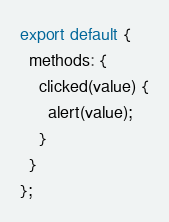Convert code to text. <code><loc_0><loc_0><loc_500><loc_500><_JavaScript_>export default {
  methods: {
    clicked(value) {
      alert(value);
    }
  }
};</code> 